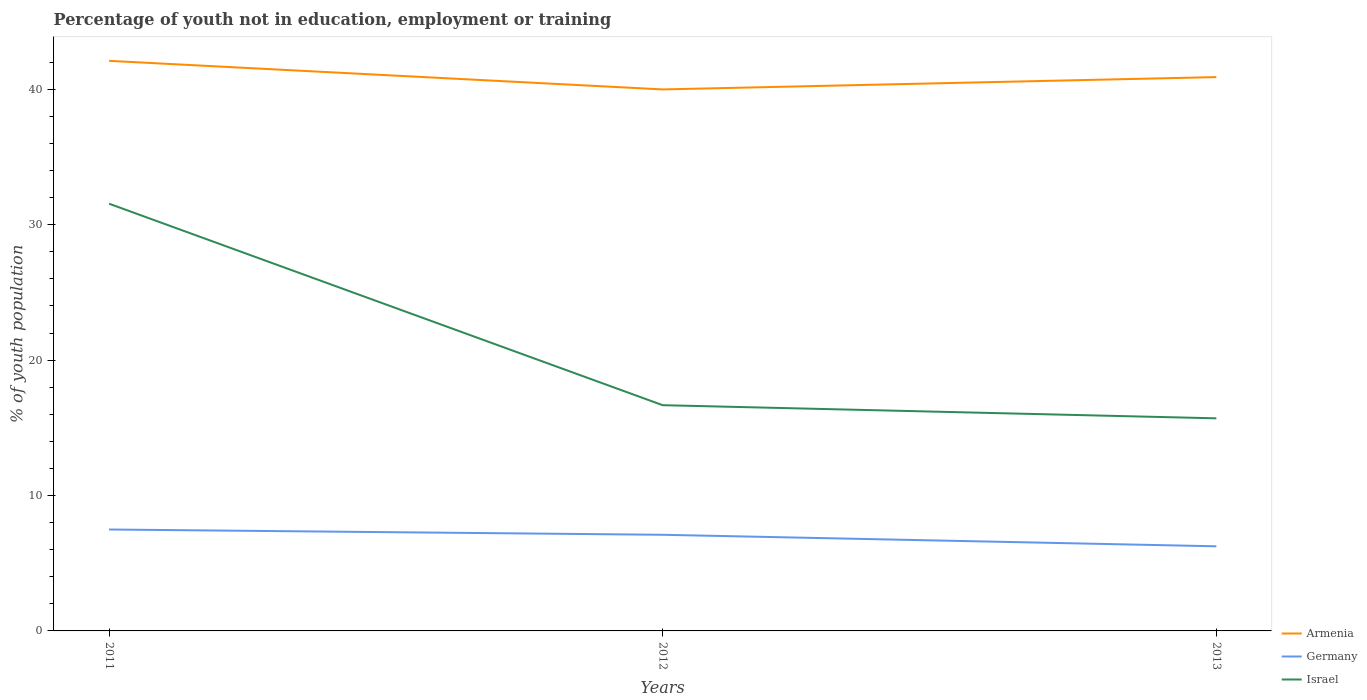How many different coloured lines are there?
Offer a very short reply. 3. Is the number of lines equal to the number of legend labels?
Provide a short and direct response. Yes. Across all years, what is the maximum percentage of unemployed youth population in in Israel?
Ensure brevity in your answer.  15.7. In which year was the percentage of unemployed youth population in in Armenia maximum?
Keep it short and to the point. 2012. What is the total percentage of unemployed youth population in in Armenia in the graph?
Give a very brief answer. 2.11. What is the difference between the highest and the second highest percentage of unemployed youth population in in Germany?
Give a very brief answer. 1.24. What is the difference between the highest and the lowest percentage of unemployed youth population in in Armenia?
Your answer should be very brief. 1. Is the percentage of unemployed youth population in in Israel strictly greater than the percentage of unemployed youth population in in Germany over the years?
Ensure brevity in your answer.  No. How many lines are there?
Your answer should be very brief. 3. How many years are there in the graph?
Your response must be concise. 3. Does the graph contain any zero values?
Provide a succinct answer. No. Where does the legend appear in the graph?
Your response must be concise. Bottom right. How are the legend labels stacked?
Provide a succinct answer. Vertical. What is the title of the graph?
Your answer should be very brief. Percentage of youth not in education, employment or training. Does "Trinidad and Tobago" appear as one of the legend labels in the graph?
Your answer should be compact. No. What is the label or title of the Y-axis?
Provide a succinct answer. % of youth population. What is the % of youth population of Armenia in 2011?
Keep it short and to the point. 42.1. What is the % of youth population in Germany in 2011?
Offer a very short reply. 7.49. What is the % of youth population in Israel in 2011?
Ensure brevity in your answer.  31.55. What is the % of youth population of Armenia in 2012?
Your answer should be compact. 39.99. What is the % of youth population of Germany in 2012?
Make the answer very short. 7.1. What is the % of youth population of Israel in 2012?
Make the answer very short. 16.67. What is the % of youth population in Armenia in 2013?
Ensure brevity in your answer.  40.9. What is the % of youth population in Germany in 2013?
Provide a succinct answer. 6.25. What is the % of youth population of Israel in 2013?
Ensure brevity in your answer.  15.7. Across all years, what is the maximum % of youth population of Armenia?
Offer a very short reply. 42.1. Across all years, what is the maximum % of youth population in Germany?
Your answer should be compact. 7.49. Across all years, what is the maximum % of youth population in Israel?
Provide a succinct answer. 31.55. Across all years, what is the minimum % of youth population in Armenia?
Keep it short and to the point. 39.99. Across all years, what is the minimum % of youth population in Germany?
Ensure brevity in your answer.  6.25. Across all years, what is the minimum % of youth population of Israel?
Provide a succinct answer. 15.7. What is the total % of youth population in Armenia in the graph?
Make the answer very short. 122.99. What is the total % of youth population of Germany in the graph?
Offer a terse response. 20.84. What is the total % of youth population in Israel in the graph?
Offer a terse response. 63.92. What is the difference between the % of youth population in Armenia in 2011 and that in 2012?
Offer a very short reply. 2.11. What is the difference between the % of youth population of Germany in 2011 and that in 2012?
Give a very brief answer. 0.39. What is the difference between the % of youth population of Israel in 2011 and that in 2012?
Your answer should be compact. 14.88. What is the difference between the % of youth population of Germany in 2011 and that in 2013?
Your answer should be very brief. 1.24. What is the difference between the % of youth population in Israel in 2011 and that in 2013?
Keep it short and to the point. 15.85. What is the difference between the % of youth population in Armenia in 2012 and that in 2013?
Provide a short and direct response. -0.91. What is the difference between the % of youth population of Germany in 2012 and that in 2013?
Provide a succinct answer. 0.85. What is the difference between the % of youth population of Armenia in 2011 and the % of youth population of Israel in 2012?
Keep it short and to the point. 25.43. What is the difference between the % of youth population of Germany in 2011 and the % of youth population of Israel in 2012?
Offer a terse response. -9.18. What is the difference between the % of youth population of Armenia in 2011 and the % of youth population of Germany in 2013?
Give a very brief answer. 35.85. What is the difference between the % of youth population of Armenia in 2011 and the % of youth population of Israel in 2013?
Offer a very short reply. 26.4. What is the difference between the % of youth population in Germany in 2011 and the % of youth population in Israel in 2013?
Offer a very short reply. -8.21. What is the difference between the % of youth population in Armenia in 2012 and the % of youth population in Germany in 2013?
Keep it short and to the point. 33.74. What is the difference between the % of youth population of Armenia in 2012 and the % of youth population of Israel in 2013?
Offer a terse response. 24.29. What is the difference between the % of youth population of Germany in 2012 and the % of youth population of Israel in 2013?
Keep it short and to the point. -8.6. What is the average % of youth population in Armenia per year?
Your answer should be very brief. 41. What is the average % of youth population in Germany per year?
Provide a short and direct response. 6.95. What is the average % of youth population in Israel per year?
Make the answer very short. 21.31. In the year 2011, what is the difference between the % of youth population in Armenia and % of youth population in Germany?
Offer a very short reply. 34.61. In the year 2011, what is the difference between the % of youth population of Armenia and % of youth population of Israel?
Make the answer very short. 10.55. In the year 2011, what is the difference between the % of youth population in Germany and % of youth population in Israel?
Your answer should be very brief. -24.06. In the year 2012, what is the difference between the % of youth population of Armenia and % of youth population of Germany?
Provide a short and direct response. 32.89. In the year 2012, what is the difference between the % of youth population in Armenia and % of youth population in Israel?
Your answer should be compact. 23.32. In the year 2012, what is the difference between the % of youth population of Germany and % of youth population of Israel?
Keep it short and to the point. -9.57. In the year 2013, what is the difference between the % of youth population of Armenia and % of youth population of Germany?
Your answer should be compact. 34.65. In the year 2013, what is the difference between the % of youth population in Armenia and % of youth population in Israel?
Give a very brief answer. 25.2. In the year 2013, what is the difference between the % of youth population in Germany and % of youth population in Israel?
Offer a very short reply. -9.45. What is the ratio of the % of youth population of Armenia in 2011 to that in 2012?
Your answer should be very brief. 1.05. What is the ratio of the % of youth population in Germany in 2011 to that in 2012?
Your answer should be compact. 1.05. What is the ratio of the % of youth population in Israel in 2011 to that in 2012?
Make the answer very short. 1.89. What is the ratio of the % of youth population of Armenia in 2011 to that in 2013?
Give a very brief answer. 1.03. What is the ratio of the % of youth population of Germany in 2011 to that in 2013?
Provide a short and direct response. 1.2. What is the ratio of the % of youth population of Israel in 2011 to that in 2013?
Give a very brief answer. 2.01. What is the ratio of the % of youth population of Armenia in 2012 to that in 2013?
Ensure brevity in your answer.  0.98. What is the ratio of the % of youth population of Germany in 2012 to that in 2013?
Your answer should be compact. 1.14. What is the ratio of the % of youth population of Israel in 2012 to that in 2013?
Your answer should be very brief. 1.06. What is the difference between the highest and the second highest % of youth population of Armenia?
Provide a short and direct response. 1.2. What is the difference between the highest and the second highest % of youth population of Germany?
Your answer should be very brief. 0.39. What is the difference between the highest and the second highest % of youth population of Israel?
Give a very brief answer. 14.88. What is the difference between the highest and the lowest % of youth population in Armenia?
Keep it short and to the point. 2.11. What is the difference between the highest and the lowest % of youth population in Germany?
Offer a terse response. 1.24. What is the difference between the highest and the lowest % of youth population of Israel?
Your answer should be very brief. 15.85. 